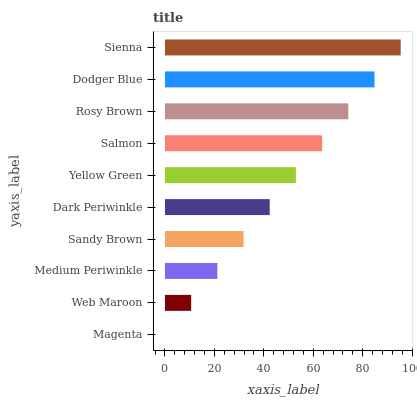Is Magenta the minimum?
Answer yes or no. Yes. Is Sienna the maximum?
Answer yes or no. Yes. Is Web Maroon the minimum?
Answer yes or no. No. Is Web Maroon the maximum?
Answer yes or no. No. Is Web Maroon greater than Magenta?
Answer yes or no. Yes. Is Magenta less than Web Maroon?
Answer yes or no. Yes. Is Magenta greater than Web Maroon?
Answer yes or no. No. Is Web Maroon less than Magenta?
Answer yes or no. No. Is Yellow Green the high median?
Answer yes or no. Yes. Is Dark Periwinkle the low median?
Answer yes or no. Yes. Is Rosy Brown the high median?
Answer yes or no. No. Is Medium Periwinkle the low median?
Answer yes or no. No. 